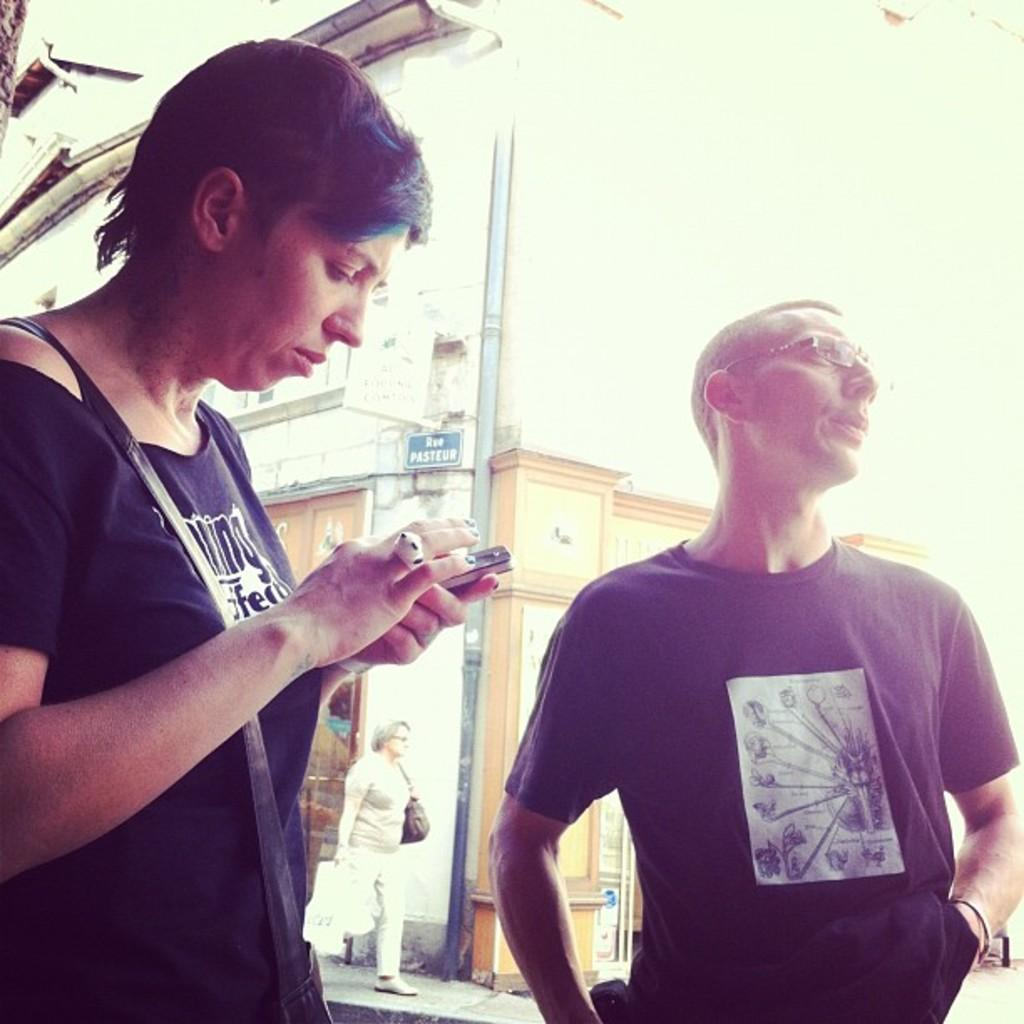How many people are in the image? There are two persons in the image. What are the people wearing? Both persons are wearing black t-shirts. What can be seen in the background of the image? There is a building in the background of the image. What is the woman in the image doing? A woman is walking in the middle of the image. What is located in the front of the image? There is a pole in the front of the image. What type of tool is the carpenter using on the ring in the image? There is no carpenter, ring, or tool present in the image. 